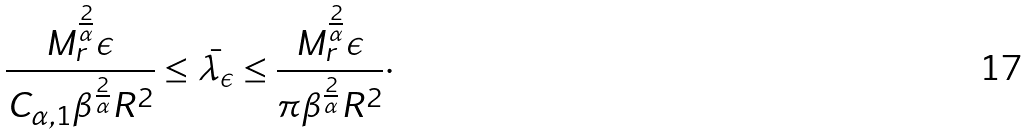Convert formula to latex. <formula><loc_0><loc_0><loc_500><loc_500>\frac { M _ { r } ^ { \frac { 2 } { \alpha } } \epsilon } { C _ { \alpha , 1 } \beta ^ { \frac { 2 } { \alpha } } R ^ { 2 } } \leq \bar { \lambda _ { \epsilon } } \leq \frac { M _ { r } ^ { \frac { 2 } { \alpha } } \epsilon } { \pi \beta ^ { \frac { 2 } { \alpha } } R ^ { 2 } } \cdot</formula> 